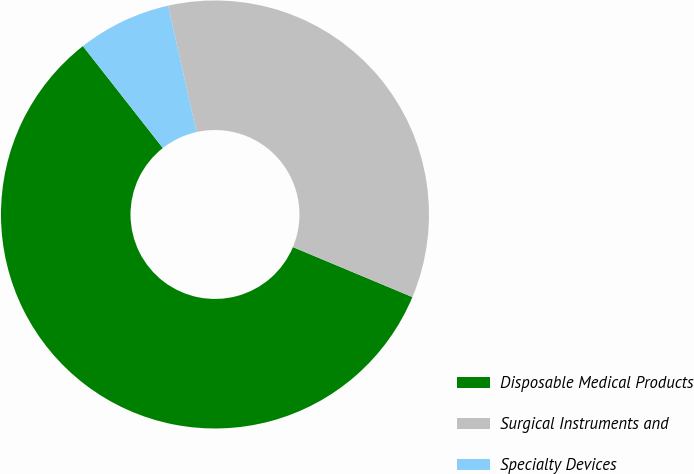<chart> <loc_0><loc_0><loc_500><loc_500><pie_chart><fcel>Disposable Medical Products<fcel>Surgical Instruments and<fcel>Specialty Devices<nl><fcel>58.11%<fcel>34.82%<fcel>7.07%<nl></chart> 